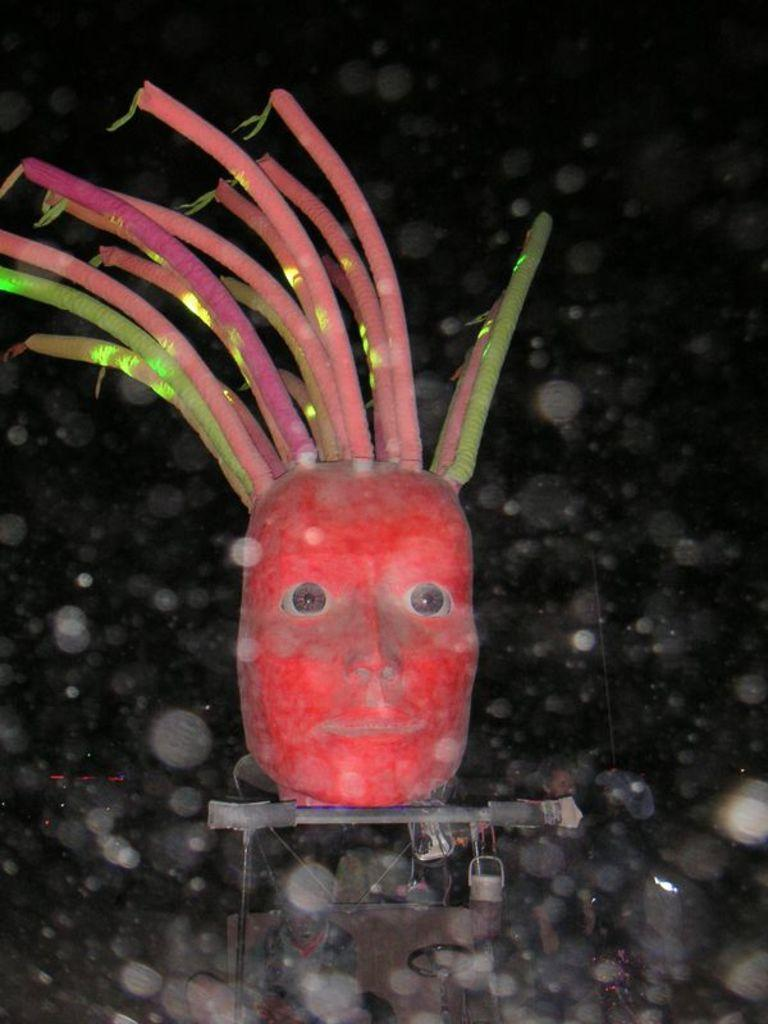What is the main subject of the image? There is a person's face in the image. What type of pear is being used for business negotiations in the image? There is no pear or business negotiations present in the image; it features a person's face. What type of flesh can be seen on the person's face in the image? The image is not detailed enough to identify specific types of flesh on the person's face. 